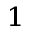<formula> <loc_0><loc_0><loc_500><loc_500>_ { 1 }</formula> 